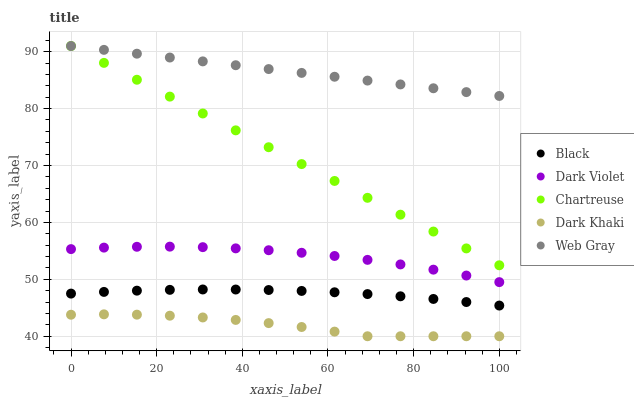Does Dark Khaki have the minimum area under the curve?
Answer yes or no. Yes. Does Web Gray have the maximum area under the curve?
Answer yes or no. Yes. Does Chartreuse have the minimum area under the curve?
Answer yes or no. No. Does Chartreuse have the maximum area under the curve?
Answer yes or no. No. Is Chartreuse the smoothest?
Answer yes or no. Yes. Is Dark Khaki the roughest?
Answer yes or no. Yes. Is Web Gray the smoothest?
Answer yes or no. No. Is Web Gray the roughest?
Answer yes or no. No. Does Dark Khaki have the lowest value?
Answer yes or no. Yes. Does Chartreuse have the lowest value?
Answer yes or no. No. Does Web Gray have the highest value?
Answer yes or no. Yes. Does Black have the highest value?
Answer yes or no. No. Is Dark Violet less than Web Gray?
Answer yes or no. Yes. Is Web Gray greater than Black?
Answer yes or no. Yes. Does Chartreuse intersect Web Gray?
Answer yes or no. Yes. Is Chartreuse less than Web Gray?
Answer yes or no. No. Is Chartreuse greater than Web Gray?
Answer yes or no. No. Does Dark Violet intersect Web Gray?
Answer yes or no. No. 